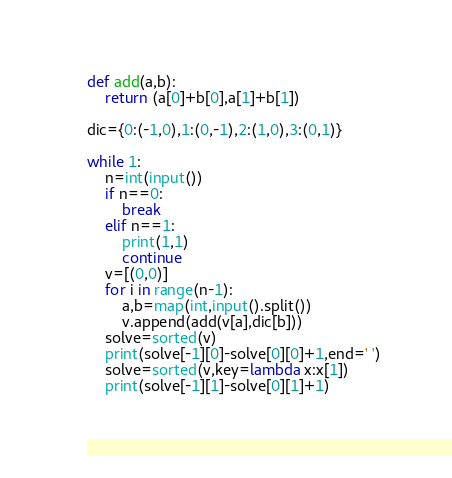Convert code to text. <code><loc_0><loc_0><loc_500><loc_500><_Python_>def add(a,b):
    return (a[0]+b[0],a[1]+b[1])
    
dic={0:(-1,0),1:(0,-1),2:(1,0),3:(0,1)}

while 1:
    n=int(input())
    if n==0:
        break
    elif n==1:
        print(1,1)
        continue
    v=[(0,0)]
    for i in range(n-1):
        a,b=map(int,input().split())
        v.append(add(v[a],dic[b]))
    solve=sorted(v)
    print(solve[-1][0]-solve[0][0]+1,end=' ')
    solve=sorted(v,key=lambda x:x[1])
    print(solve[-1][1]-solve[0][1]+1)  
        
</code> 